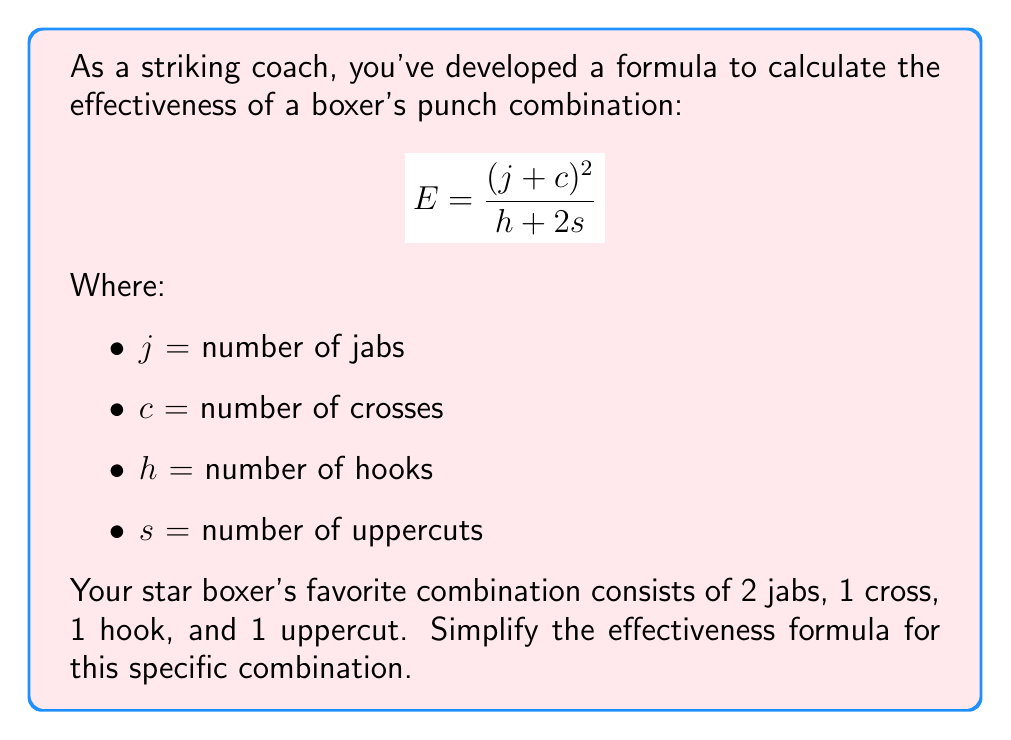Could you help me with this problem? Let's approach this step-by-step:

1) First, let's substitute the values into our formula:
   $j = 2$ (2 jabs)
   $c = 1$ (1 cross)
   $h = 1$ (1 hook)
   $s = 1$ (1 uppercut)

2) Now, let's plug these values into our formula:

   $$E = \frac{(j+c)^2}{h+2s}$$

   $$E = \frac{(2+1)^2}{1+2(1)}$$

3) Simplify the numerator:
   $$E = \frac{3^2}{1+2(1)}$$
   $$E = \frac{9}{1+2(1)}$$

4) Simplify the denominator:
   $$E = \frac{9}{1+2}$$
   $$E = \frac{9}{3}$$

5) Divide:
   $$E = 3$$

Thus, the simplified expression for this specific combination is 3.
Answer: $3$ 